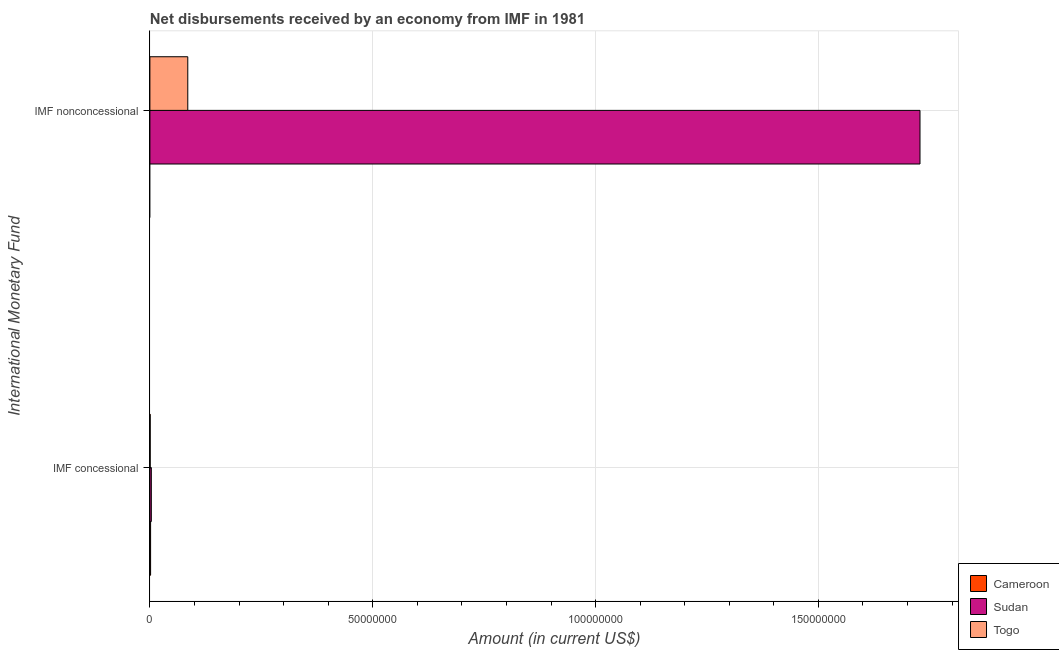How many different coloured bars are there?
Keep it short and to the point. 3. How many groups of bars are there?
Give a very brief answer. 2. Are the number of bars per tick equal to the number of legend labels?
Your response must be concise. No. How many bars are there on the 1st tick from the top?
Ensure brevity in your answer.  2. How many bars are there on the 2nd tick from the bottom?
Your answer should be compact. 2. What is the label of the 2nd group of bars from the top?
Offer a terse response. IMF concessional. What is the net non concessional disbursements from imf in Togo?
Your response must be concise. 8.50e+06. Across all countries, what is the maximum net concessional disbursements from imf?
Offer a terse response. 3.20e+05. In which country was the net non concessional disbursements from imf maximum?
Give a very brief answer. Sudan. What is the total net non concessional disbursements from imf in the graph?
Your answer should be compact. 1.81e+08. What is the difference between the net non concessional disbursements from imf in Togo and that in Sudan?
Provide a short and direct response. -1.64e+08. What is the difference between the net non concessional disbursements from imf in Cameroon and the net concessional disbursements from imf in Sudan?
Provide a short and direct response. -3.20e+05. What is the average net concessional disbursements from imf per country?
Your answer should be very brief. 1.81e+05. What is the difference between the net concessional disbursements from imf and net non concessional disbursements from imf in Sudan?
Give a very brief answer. -1.72e+08. What is the ratio of the net concessional disbursements from imf in Togo to that in Cameroon?
Your answer should be compact. 0.43. In how many countries, is the net concessional disbursements from imf greater than the average net concessional disbursements from imf taken over all countries?
Provide a succinct answer. 1. Are all the bars in the graph horizontal?
Ensure brevity in your answer.  Yes. Are the values on the major ticks of X-axis written in scientific E-notation?
Give a very brief answer. No. What is the title of the graph?
Offer a very short reply. Net disbursements received by an economy from IMF in 1981. What is the label or title of the X-axis?
Offer a terse response. Amount (in current US$). What is the label or title of the Y-axis?
Ensure brevity in your answer.  International Monetary Fund. What is the Amount (in current US$) in Cameroon in IMF concessional?
Keep it short and to the point. 1.56e+05. What is the Amount (in current US$) in Sudan in IMF concessional?
Ensure brevity in your answer.  3.20e+05. What is the Amount (in current US$) in Togo in IMF concessional?
Make the answer very short. 6.70e+04. What is the Amount (in current US$) in Sudan in IMF nonconcessional?
Offer a terse response. 1.73e+08. What is the Amount (in current US$) in Togo in IMF nonconcessional?
Offer a terse response. 8.50e+06. Across all International Monetary Fund, what is the maximum Amount (in current US$) in Cameroon?
Offer a very short reply. 1.56e+05. Across all International Monetary Fund, what is the maximum Amount (in current US$) in Sudan?
Make the answer very short. 1.73e+08. Across all International Monetary Fund, what is the maximum Amount (in current US$) of Togo?
Offer a very short reply. 8.50e+06. Across all International Monetary Fund, what is the minimum Amount (in current US$) of Sudan?
Provide a succinct answer. 3.20e+05. Across all International Monetary Fund, what is the minimum Amount (in current US$) of Togo?
Provide a succinct answer. 6.70e+04. What is the total Amount (in current US$) of Cameroon in the graph?
Give a very brief answer. 1.56e+05. What is the total Amount (in current US$) in Sudan in the graph?
Offer a very short reply. 1.73e+08. What is the total Amount (in current US$) of Togo in the graph?
Give a very brief answer. 8.57e+06. What is the difference between the Amount (in current US$) in Sudan in IMF concessional and that in IMF nonconcessional?
Provide a short and direct response. -1.72e+08. What is the difference between the Amount (in current US$) in Togo in IMF concessional and that in IMF nonconcessional?
Offer a terse response. -8.43e+06. What is the difference between the Amount (in current US$) in Cameroon in IMF concessional and the Amount (in current US$) in Sudan in IMF nonconcessional?
Keep it short and to the point. -1.73e+08. What is the difference between the Amount (in current US$) in Cameroon in IMF concessional and the Amount (in current US$) in Togo in IMF nonconcessional?
Give a very brief answer. -8.34e+06. What is the difference between the Amount (in current US$) in Sudan in IMF concessional and the Amount (in current US$) in Togo in IMF nonconcessional?
Your answer should be very brief. -8.18e+06. What is the average Amount (in current US$) in Cameroon per International Monetary Fund?
Offer a terse response. 7.80e+04. What is the average Amount (in current US$) of Sudan per International Monetary Fund?
Your answer should be very brief. 8.66e+07. What is the average Amount (in current US$) of Togo per International Monetary Fund?
Make the answer very short. 4.28e+06. What is the difference between the Amount (in current US$) of Cameroon and Amount (in current US$) of Sudan in IMF concessional?
Your response must be concise. -1.64e+05. What is the difference between the Amount (in current US$) of Cameroon and Amount (in current US$) of Togo in IMF concessional?
Keep it short and to the point. 8.90e+04. What is the difference between the Amount (in current US$) in Sudan and Amount (in current US$) in Togo in IMF concessional?
Your answer should be very brief. 2.53e+05. What is the difference between the Amount (in current US$) of Sudan and Amount (in current US$) of Togo in IMF nonconcessional?
Offer a terse response. 1.64e+08. What is the ratio of the Amount (in current US$) in Sudan in IMF concessional to that in IMF nonconcessional?
Keep it short and to the point. 0. What is the ratio of the Amount (in current US$) of Togo in IMF concessional to that in IMF nonconcessional?
Offer a very short reply. 0.01. What is the difference between the highest and the second highest Amount (in current US$) of Sudan?
Your answer should be compact. 1.72e+08. What is the difference between the highest and the second highest Amount (in current US$) in Togo?
Your response must be concise. 8.43e+06. What is the difference between the highest and the lowest Amount (in current US$) of Cameroon?
Provide a succinct answer. 1.56e+05. What is the difference between the highest and the lowest Amount (in current US$) of Sudan?
Provide a succinct answer. 1.72e+08. What is the difference between the highest and the lowest Amount (in current US$) of Togo?
Ensure brevity in your answer.  8.43e+06. 